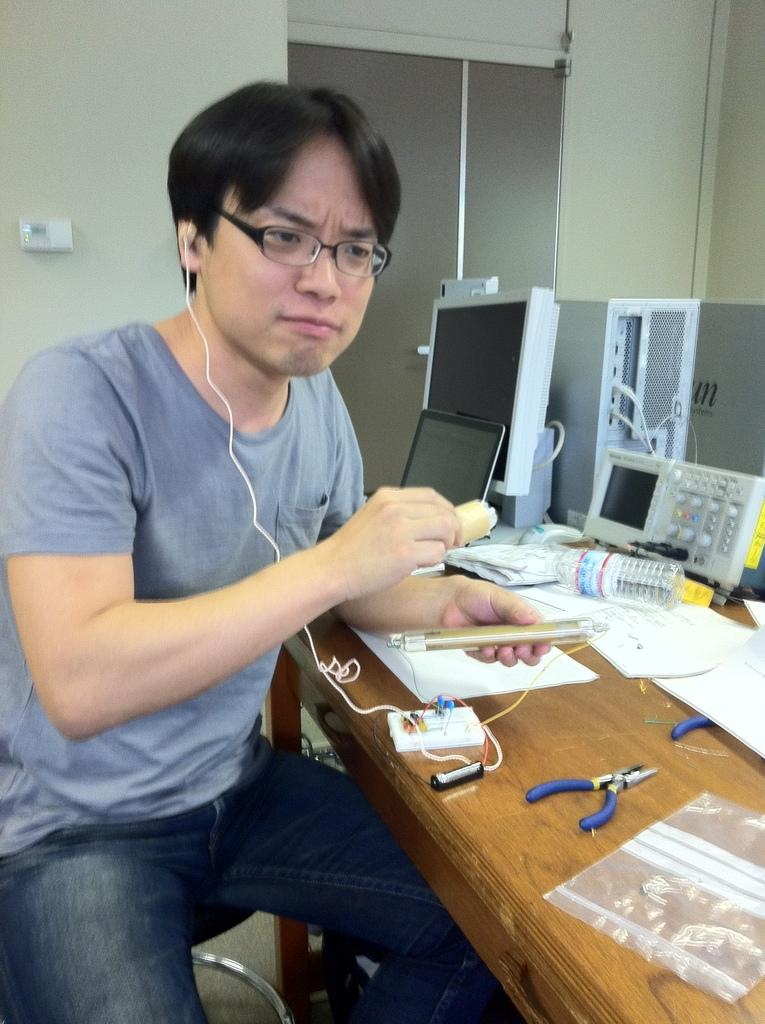What is the man in the image holding? The man is holding an electronic device. What is in front of the man? There is a table in front of the man. What other objects can be seen in the image? There are equipment, papers, and a bottle in the image. What is visible in the background of the image? There is a wall in the background of the image. What type of net can be seen in the image? There is no net present in the image. What color is the copper in the image? There is no copper present in the image. 